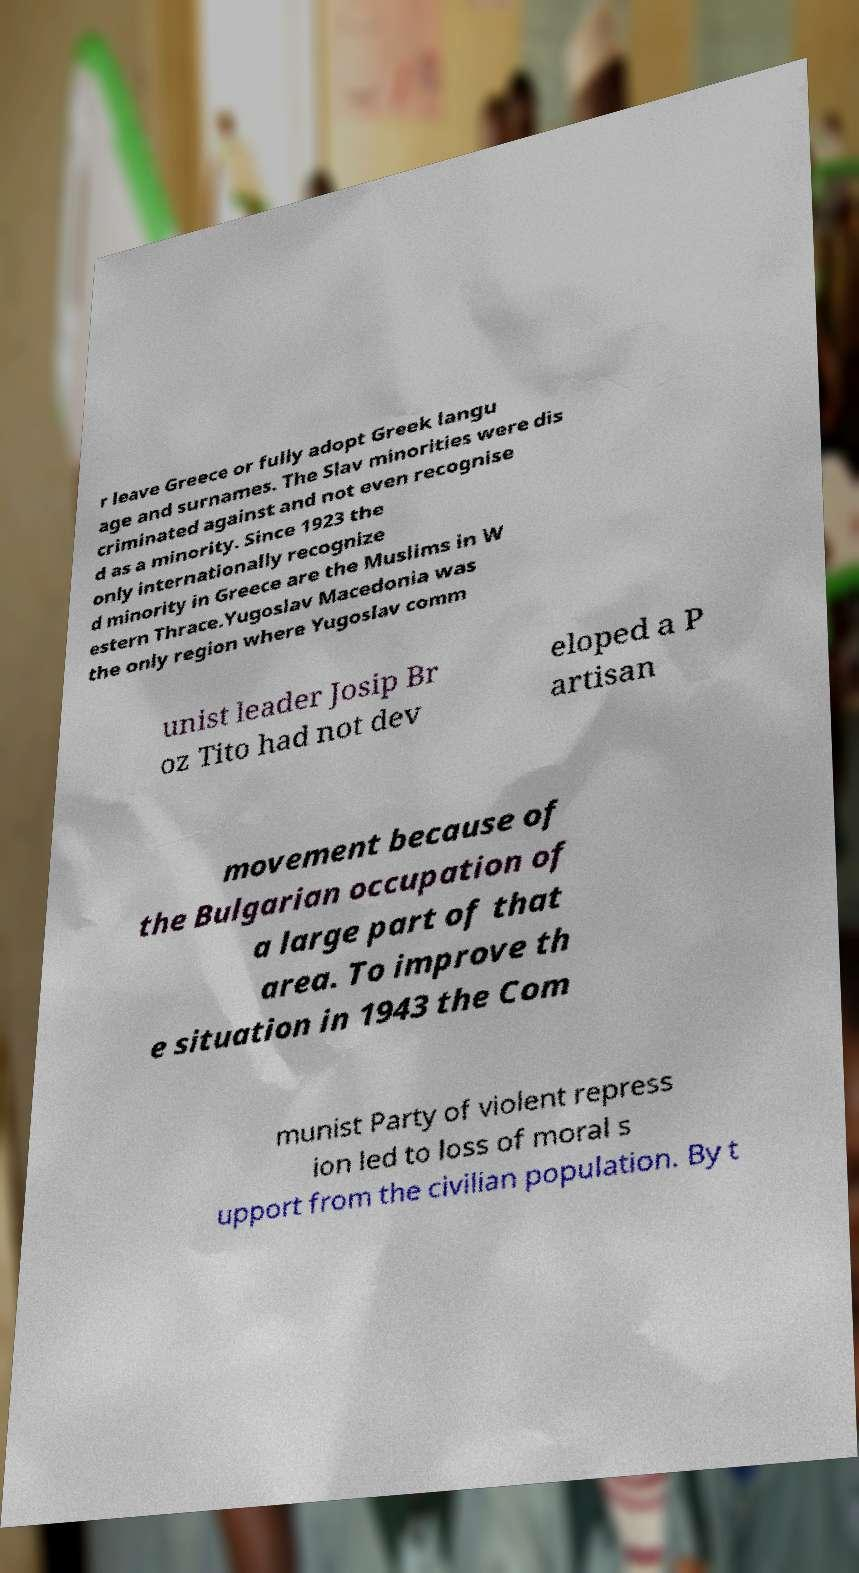Please identify and transcribe the text found in this image. r leave Greece or fully adopt Greek langu age and surnames. The Slav minorities were dis criminated against and not even recognise d as a minority. Since 1923 the only internationally recognize d minority in Greece are the Muslims in W estern Thrace.Yugoslav Macedonia was the only region where Yugoslav comm unist leader Josip Br oz Tito had not dev eloped a P artisan movement because of the Bulgarian occupation of a large part of that area. To improve th e situation in 1943 the Com munist Party of violent repress ion led to loss of moral s upport from the civilian population. By t 